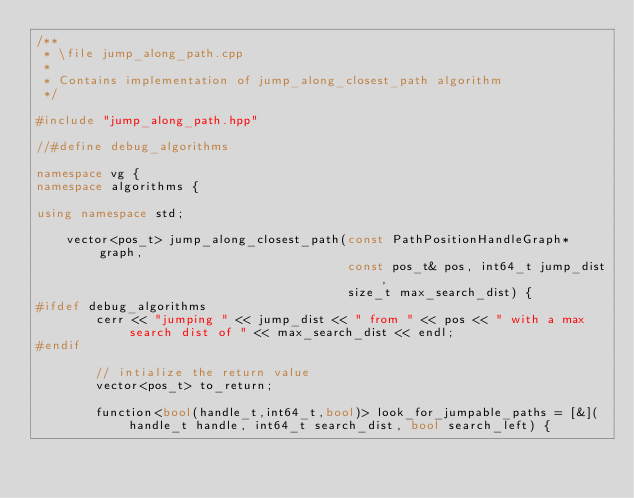<code> <loc_0><loc_0><loc_500><loc_500><_C++_>/**
 * \file jump_along_path.cpp
 *
 * Contains implementation of jump_along_closest_path algorithm
 */

#include "jump_along_path.hpp"

//#define debug_algorithms

namespace vg {
namespace algorithms {

using namespace std;

    vector<pos_t> jump_along_closest_path(const PathPositionHandleGraph* graph,
                                          const pos_t& pos, int64_t jump_dist,
                                          size_t max_search_dist) {
#ifdef debug_algorithms
        cerr << "jumping " << jump_dist << " from " << pos << " with a max search dist of " << max_search_dist << endl;
#endif
        
        // intialize the return value
        vector<pos_t> to_return;
        
        function<bool(handle_t,int64_t,bool)> look_for_jumpable_paths = [&](handle_t handle, int64_t search_dist, bool search_left) {
            </code> 